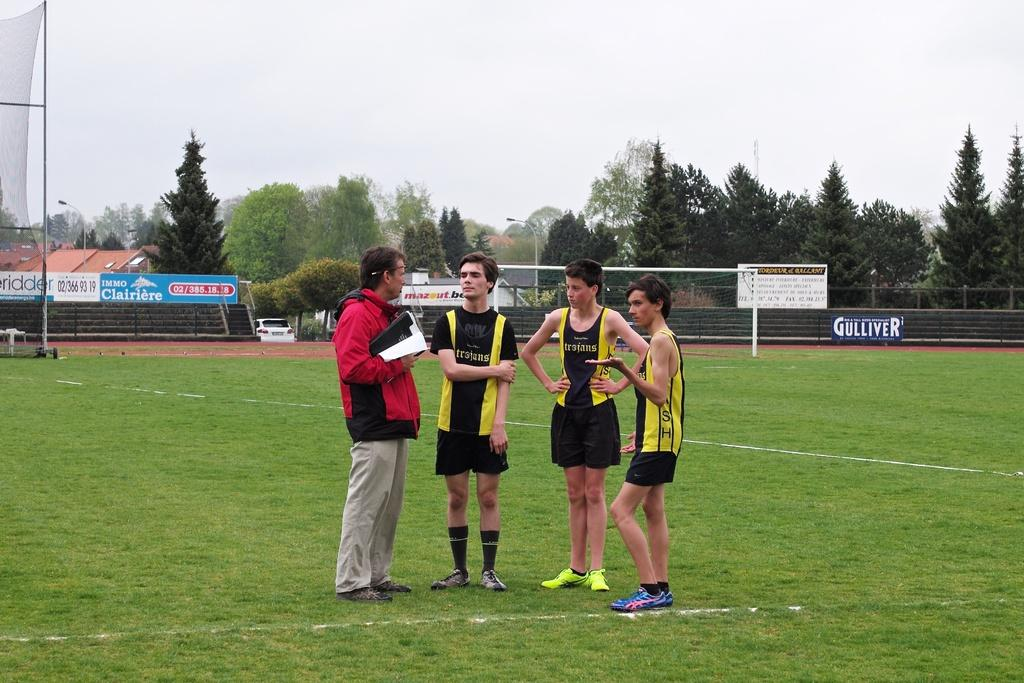<image>
Offer a succinct explanation of the picture presented. A man and three Trojans athletes have a discussion. 